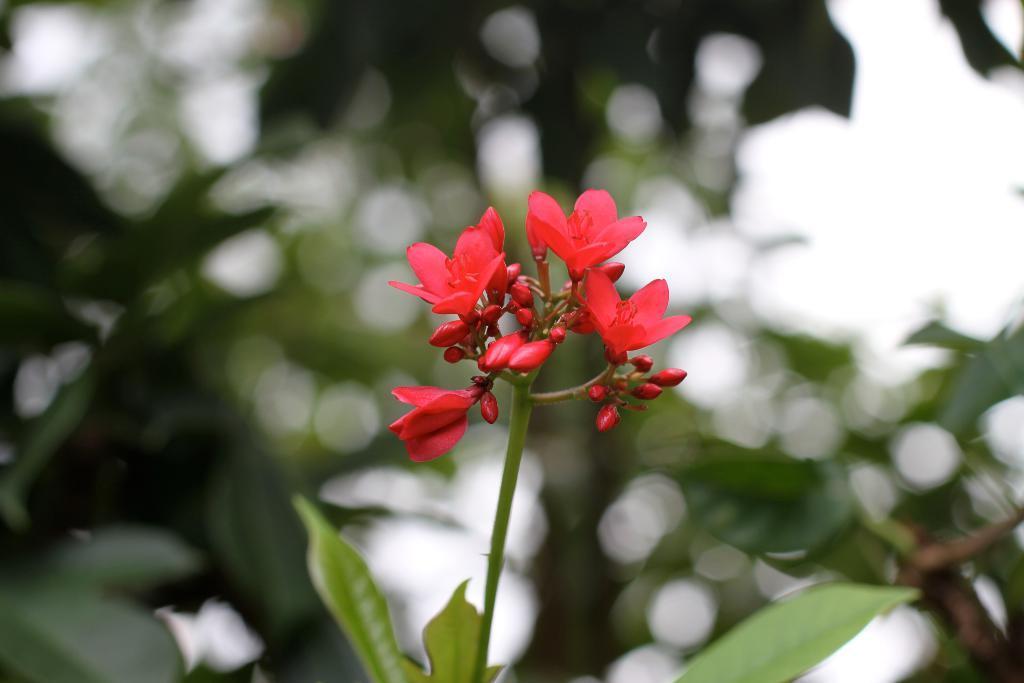Could you give a brief overview of what you see in this image? In this picture we can see a few red flowers, buds, stem and leaves. Background is blurry. 